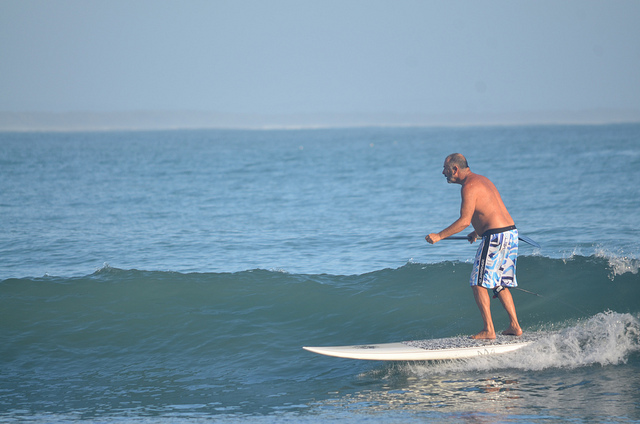<image>What is on this person's finger? I don't know what is on this person's finger. It can be a paddle, a ring or nothing. What is on this person's finger? I don't know what is on this person's finger. It can be a paddle, oar, or ring. 